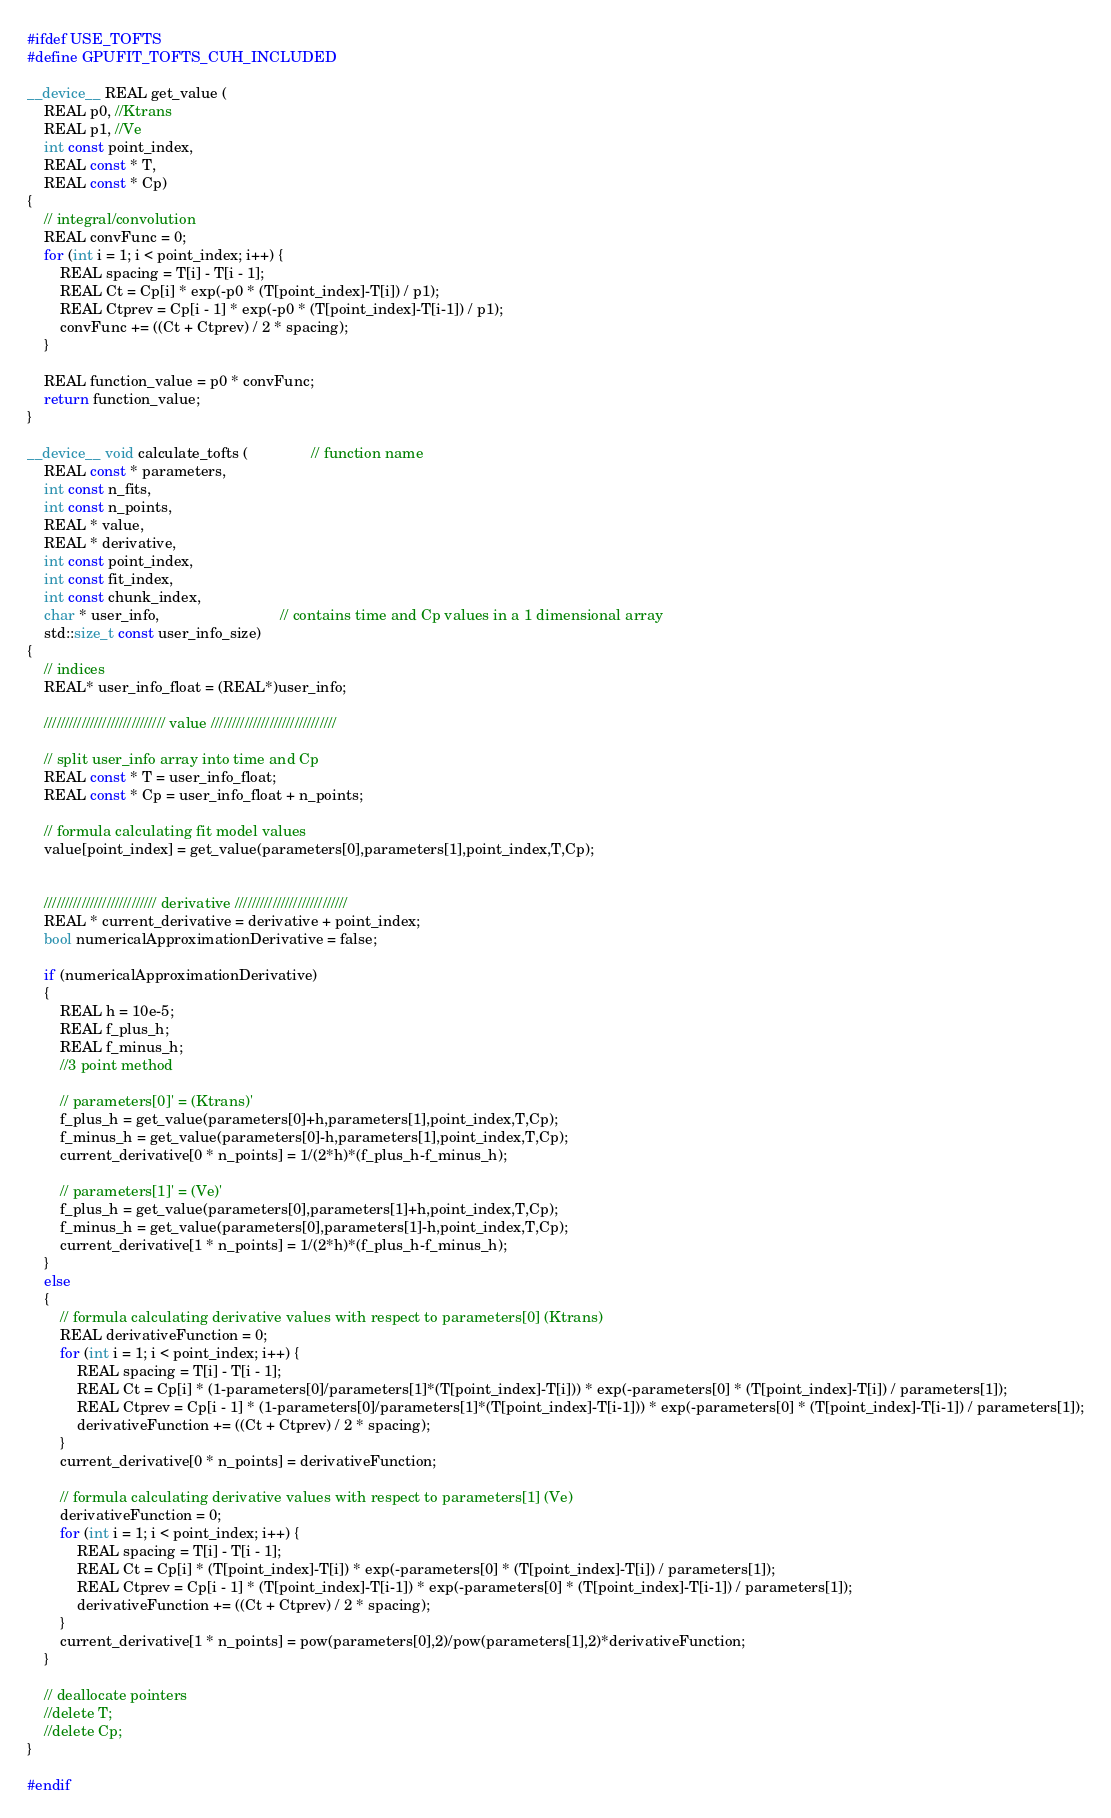<code> <loc_0><loc_0><loc_500><loc_500><_Cuda_>#ifdef USE_TOFTS
#define GPUFIT_TOFTS_CUH_INCLUDED

__device__ REAL get_value (
	REAL p0, //Ktrans
	REAL p1, //Ve
	int const point_index,
	REAL const * T,
	REAL const * Cp)
{
	// integral/convolution
	REAL convFunc = 0;
	for (int i = 1; i < point_index; i++) {
		REAL spacing = T[i] - T[i - 1];
		REAL Ct = Cp[i] * exp(-p0 * (T[point_index]-T[i]) / p1);
		REAL Ctprev = Cp[i - 1] * exp(-p0 * (T[point_index]-T[i-1]) / p1);
		convFunc += ((Ct + Ctprev) / 2 * spacing);
	}

	REAL function_value = p0 * convFunc;
	return function_value;
}

__device__ void calculate_tofts (               // function name
	REAL const * parameters,
	int const n_fits,
	int const n_points,
	REAL * value,
	REAL * derivative,
	int const point_index,						 
	int const fit_index,
	int const chunk_index,
	char * user_info,							 // contains time and Cp values in a 1 dimensional array
	std::size_t const user_info_size)
{
	// indices
	REAL* user_info_float = (REAL*)user_info;

	///////////////////////////// value //////////////////////////////

	// split user_info array into time and Cp
	REAL const * T = user_info_float;
	REAL const * Cp = user_info_float + n_points;

	// formula calculating fit model values
	value[point_index] = get_value(parameters[0],parameters[1],point_index,T,Cp);


	/////////////////////////// derivative ///////////////////////////
	REAL * current_derivative = derivative + point_index;
	bool numericalApproximationDerivative = false;

	if (numericalApproximationDerivative)
	{
		REAL h = 10e-5;
		REAL f_plus_h;
		REAL f_minus_h;
		//3 point method

		// parameters[0]' = (Ktrans)'
		f_plus_h = get_value(parameters[0]+h,parameters[1],point_index,T,Cp);
		f_minus_h = get_value(parameters[0]-h,parameters[1],point_index,T,Cp);
		current_derivative[0 * n_points] = 1/(2*h)*(f_plus_h-f_minus_h);

		// parameters[1]' = (Ve)'
		f_plus_h = get_value(parameters[0],parameters[1]+h,point_index,T,Cp);
		f_minus_h = get_value(parameters[0],parameters[1]-h,point_index,T,Cp);
		current_derivative[1 * n_points] = 1/(2*h)*(f_plus_h-f_minus_h);
	}
	else
	{
		// formula calculating derivative values with respect to parameters[0] (Ktrans)
		REAL derivativeFunction = 0;
		for (int i = 1; i < point_index; i++) {
			REAL spacing = T[i] - T[i - 1];
			REAL Ct = Cp[i] * (1-parameters[0]/parameters[1]*(T[point_index]-T[i])) * exp(-parameters[0] * (T[point_index]-T[i]) / parameters[1]);
			REAL Ctprev = Cp[i - 1] * (1-parameters[0]/parameters[1]*(T[point_index]-T[i-1])) * exp(-parameters[0] * (T[point_index]-T[i-1]) / parameters[1]);
			derivativeFunction += ((Ct + Ctprev) / 2 * spacing);
		}
		current_derivative[0 * n_points] = derivativeFunction;

		// formula calculating derivative values with respect to parameters[1] (Ve)
		derivativeFunction = 0;
		for (int i = 1; i < point_index; i++) {
			REAL spacing = T[i] - T[i - 1];
			REAL Ct = Cp[i] * (T[point_index]-T[i]) * exp(-parameters[0] * (T[point_index]-T[i]) / parameters[1]);
			REAL Ctprev = Cp[i - 1] * (T[point_index]-T[i-1]) * exp(-parameters[0] * (T[point_index]-T[i-1]) / parameters[1]);
			derivativeFunction += ((Ct + Ctprev) / 2 * spacing);
		}
		current_derivative[1 * n_points] = pow(parameters[0],2)/pow(parameters[1],2)*derivativeFunction;
	}

	// deallocate pointers
	//delete T;
	//delete Cp;
}

#endif
</code> 